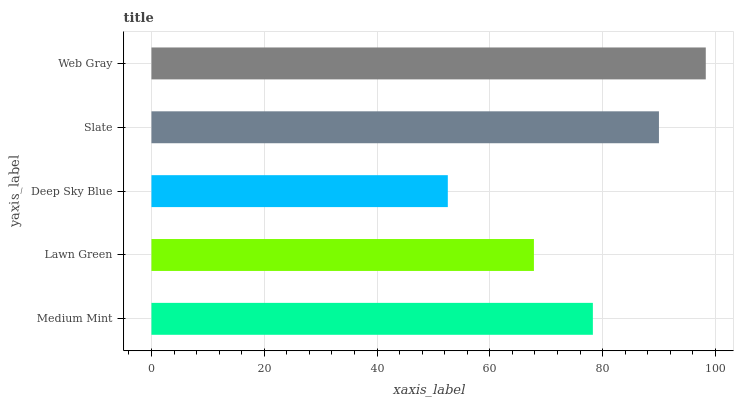Is Deep Sky Blue the minimum?
Answer yes or no. Yes. Is Web Gray the maximum?
Answer yes or no. Yes. Is Lawn Green the minimum?
Answer yes or no. No. Is Lawn Green the maximum?
Answer yes or no. No. Is Medium Mint greater than Lawn Green?
Answer yes or no. Yes. Is Lawn Green less than Medium Mint?
Answer yes or no. Yes. Is Lawn Green greater than Medium Mint?
Answer yes or no. No. Is Medium Mint less than Lawn Green?
Answer yes or no. No. Is Medium Mint the high median?
Answer yes or no. Yes. Is Medium Mint the low median?
Answer yes or no. Yes. Is Web Gray the high median?
Answer yes or no. No. Is Deep Sky Blue the low median?
Answer yes or no. No. 